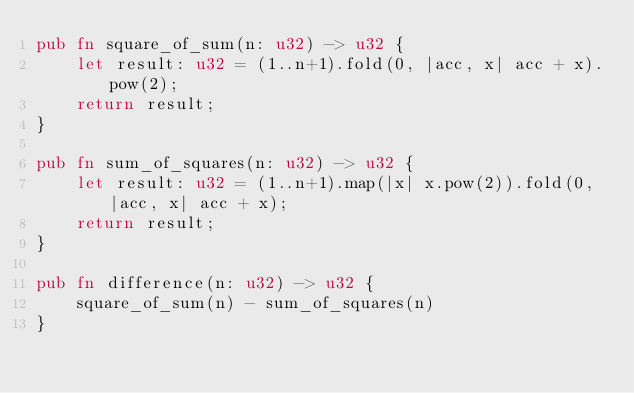<code> <loc_0><loc_0><loc_500><loc_500><_Rust_>pub fn square_of_sum(n: u32) -> u32 {
    let result: u32 = (1..n+1).fold(0, |acc, x| acc + x).pow(2);
    return result;
}

pub fn sum_of_squares(n: u32) -> u32 {
    let result: u32 = (1..n+1).map(|x| x.pow(2)).fold(0, |acc, x| acc + x);
    return result;
}

pub fn difference(n: u32) -> u32 {
    square_of_sum(n) - sum_of_squares(n)
}
</code> 